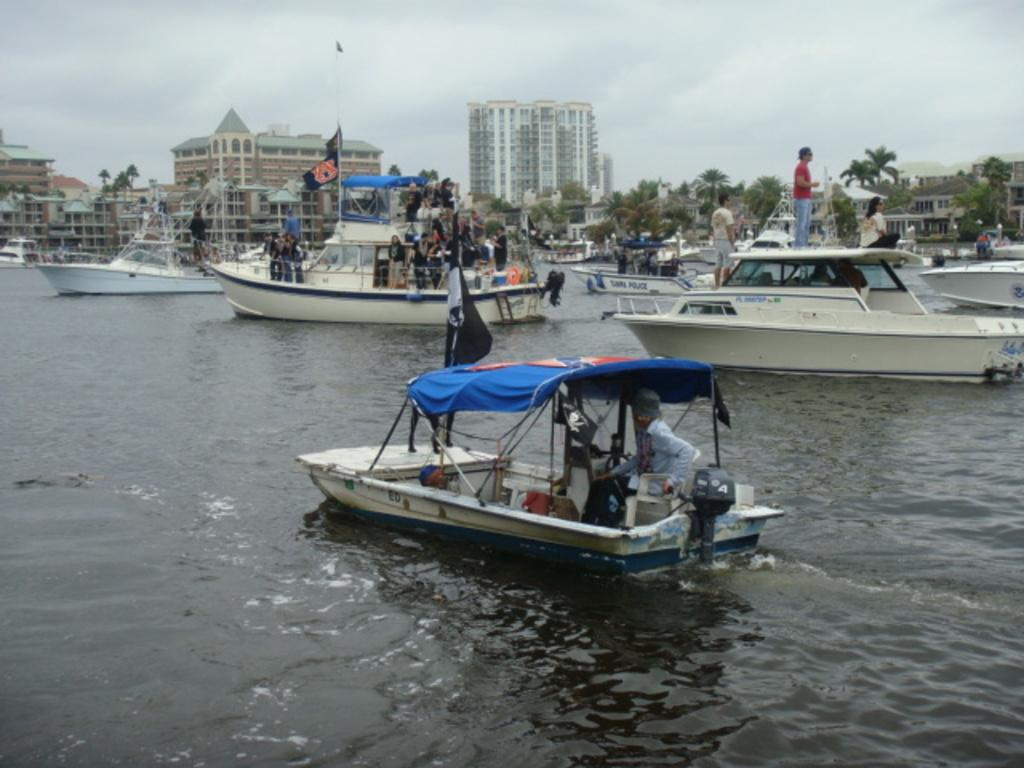What is on the water in the image? There are boats on the water in the image. What structures can be seen in the image? There are buildings in the image. What type of vegetation is present in the image? There are trees in the image. Who or what else is visible in the image? There are people in the image. What additional elements can be seen in the image? There are flags in the image. What can be seen in the background of the image? The sky with clouds is visible in the background of the image. What type of flower is growing on the boats in the image? There are no flowers growing on the boats in the image; they are boats on the water. What type of vacation is being taken in the image? The image does not depict a vacation; it shows boats, buildings, trees, people, flags, and a sky with clouds. 